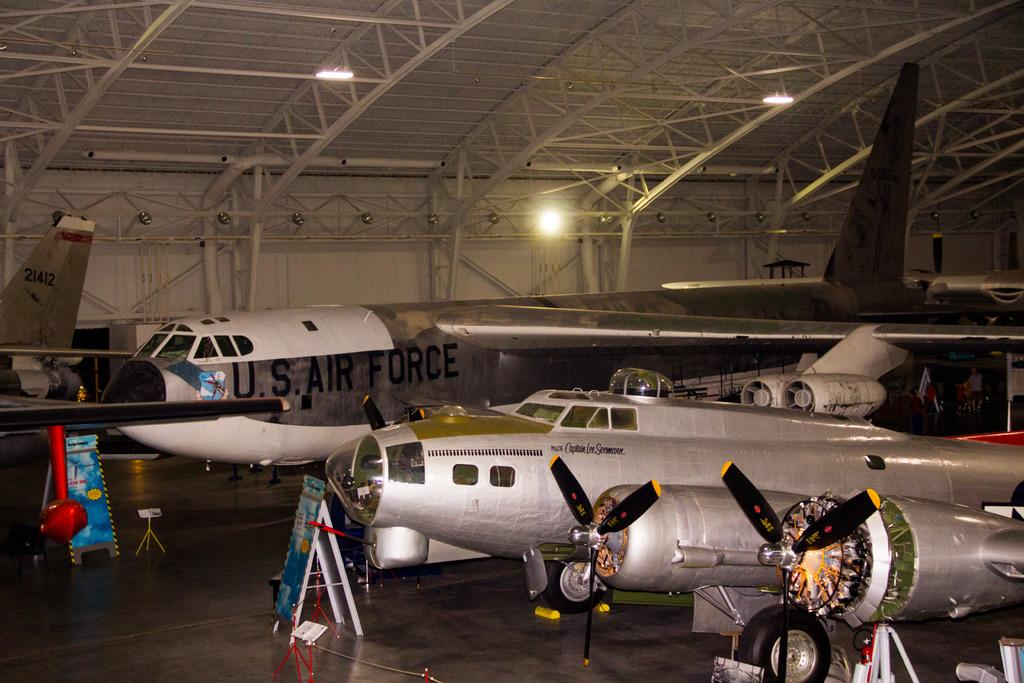<image>
Present a compact description of the photo's key features. a U.S. airforce hangar with three planes parked inside and people working on em. 